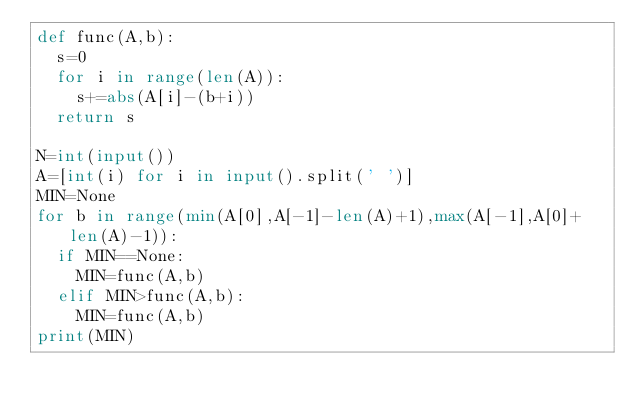Convert code to text. <code><loc_0><loc_0><loc_500><loc_500><_Python_>def func(A,b):
  s=0
  for i in range(len(A)):
    s+=abs(A[i]-(b+i))
  return s

N=int(input())
A=[int(i) for i in input().split(' ')]
MIN=None
for b in range(min(A[0],A[-1]-len(A)+1),max(A[-1],A[0]+len(A)-1)):
  if MIN==None:
    MIN=func(A,b)
  elif MIN>func(A,b):
    MIN=func(A,b)
print(MIN)</code> 